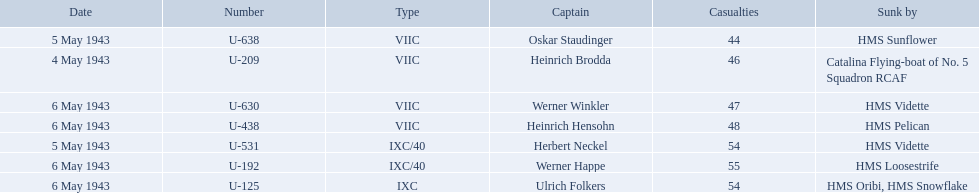Who were the captains in the ons 5 convoy? Heinrich Brodda, Oskar Staudinger, Herbert Neckel, Werner Happe, Ulrich Folkers, Werner Winkler, Heinrich Hensohn. Which ones lost their u-boat on may 5? Oskar Staudinger, Herbert Neckel. Of those, which one is not oskar staudinger? Herbert Neckel. 